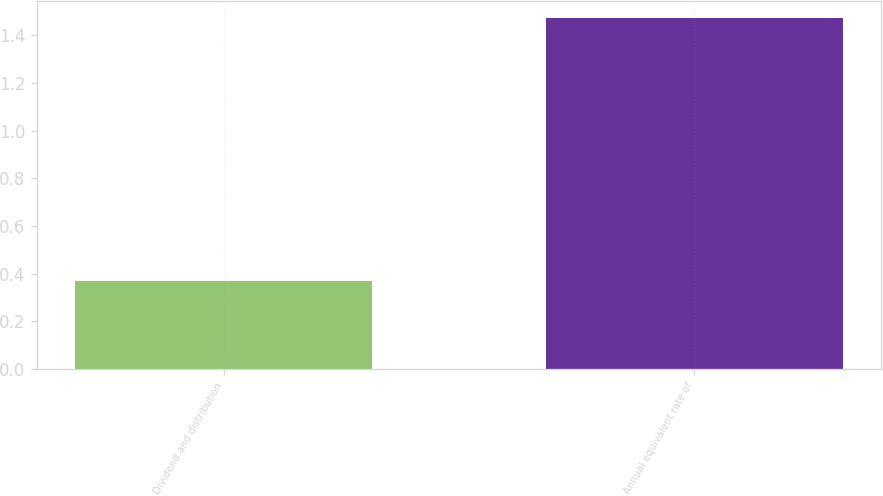<chart> <loc_0><loc_0><loc_500><loc_500><bar_chart><fcel>Dividend and distribution<fcel>Annual equivalent rate of<nl><fcel>0.37<fcel>1.47<nl></chart> 